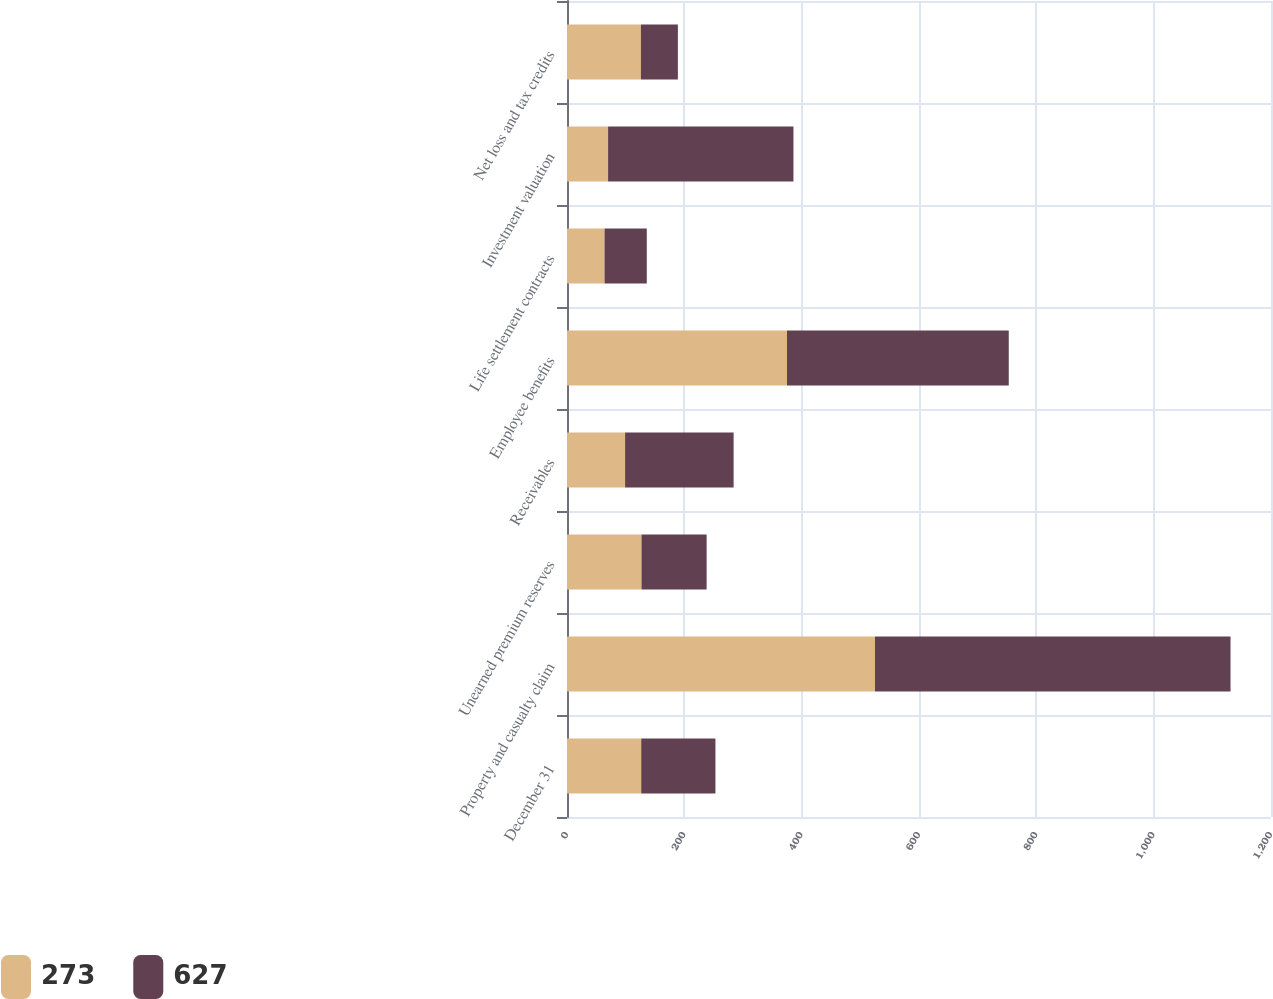Convert chart to OTSL. <chart><loc_0><loc_0><loc_500><loc_500><stacked_bar_chart><ecel><fcel>December 31<fcel>Property and casualty claim<fcel>Unearned premium reserves<fcel>Receivables<fcel>Employee benefits<fcel>Life settlement contracts<fcel>Investment valuation<fcel>Net loss and tax credits<nl><fcel>273<fcel>126.5<fcel>525<fcel>127<fcel>99<fcel>375<fcel>64<fcel>70<fcel>126<nl><fcel>627<fcel>126.5<fcel>606<fcel>111<fcel>185<fcel>378<fcel>72<fcel>316<fcel>63<nl></chart> 